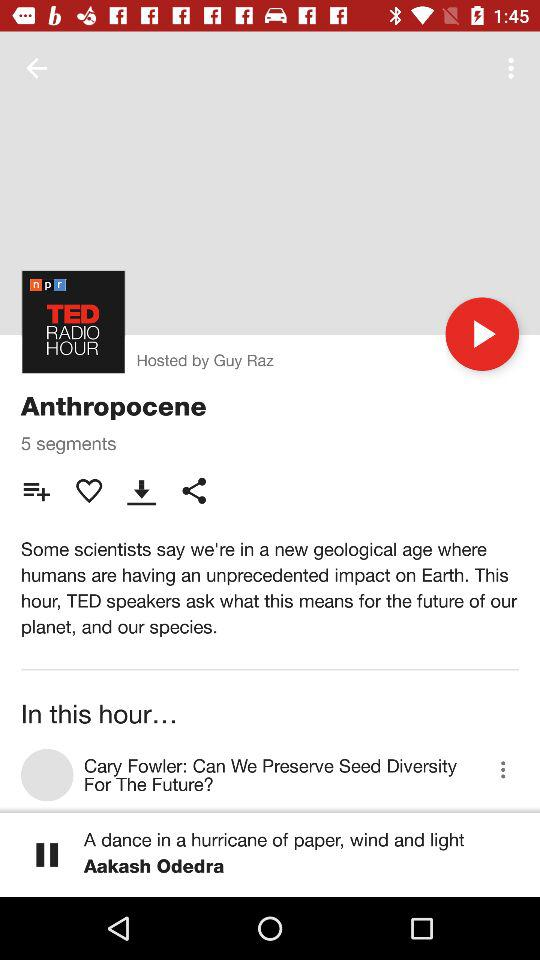How many segments are there in this episode?
Answer the question using a single word or phrase. 5 